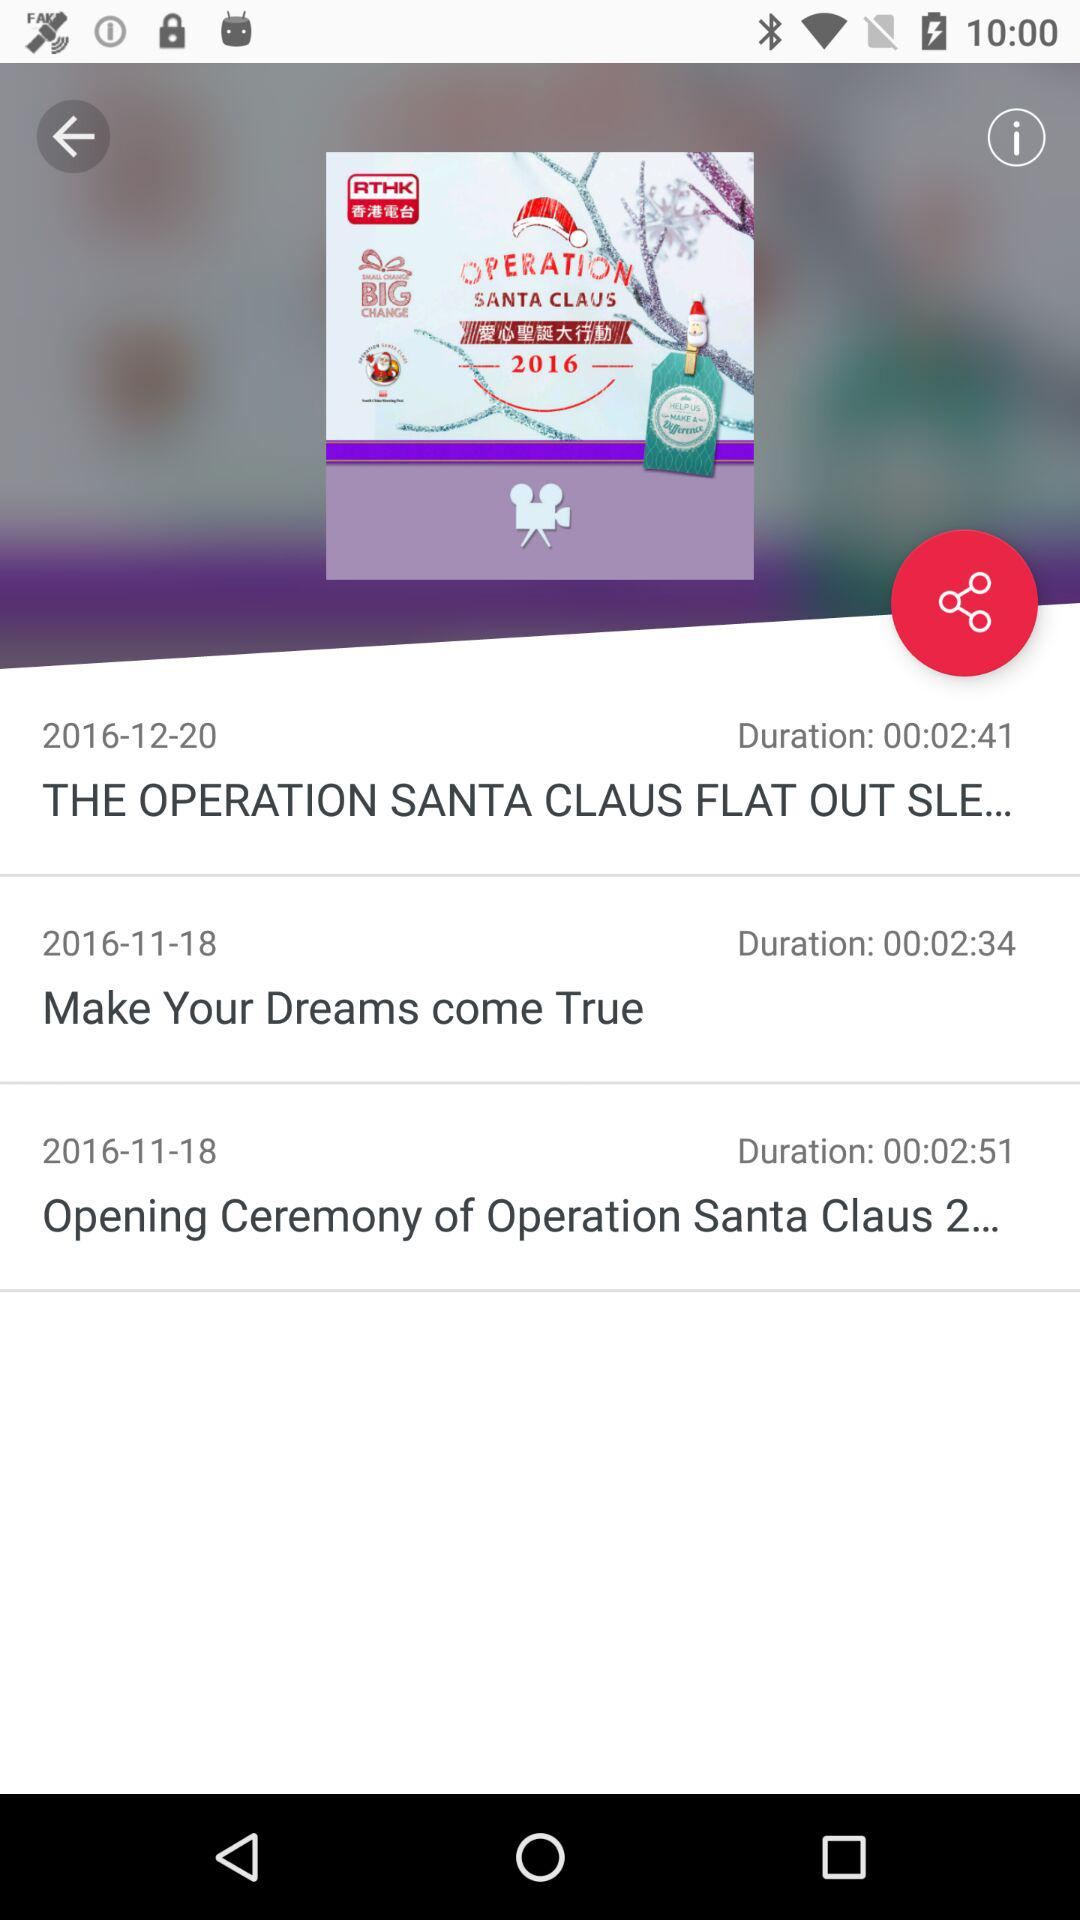What is the date of the "Opening Ceremony of Operation Santa Claus 2"? The date is November 18, 2016. 